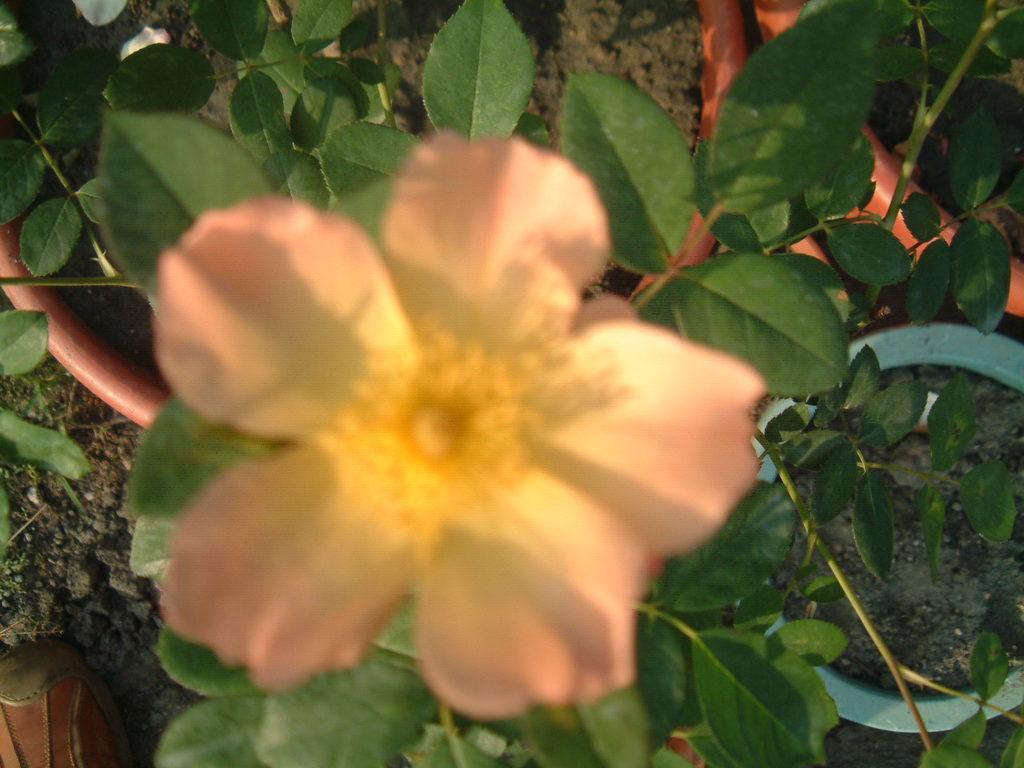In one or two sentences, can you explain what this image depicts? This image consists of a plant. It has a flower. There is pipe in the middle. 